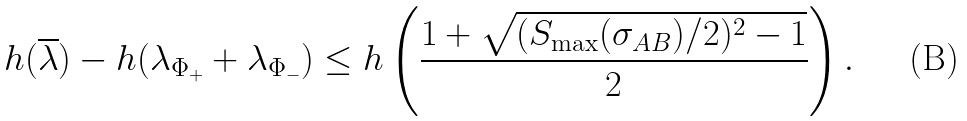<formula> <loc_0><loc_0><loc_500><loc_500>h ( \overline { \lambda } ) - h ( \lambda _ { \Phi _ { + } } + \lambda _ { \Phi _ { - } } ) \leq h \left ( \frac { 1 + \sqrt { ( S _ { \max } ( \sigma _ { A B } ) / 2 ) ^ { 2 } - 1 } } { 2 } \right ) .</formula> 